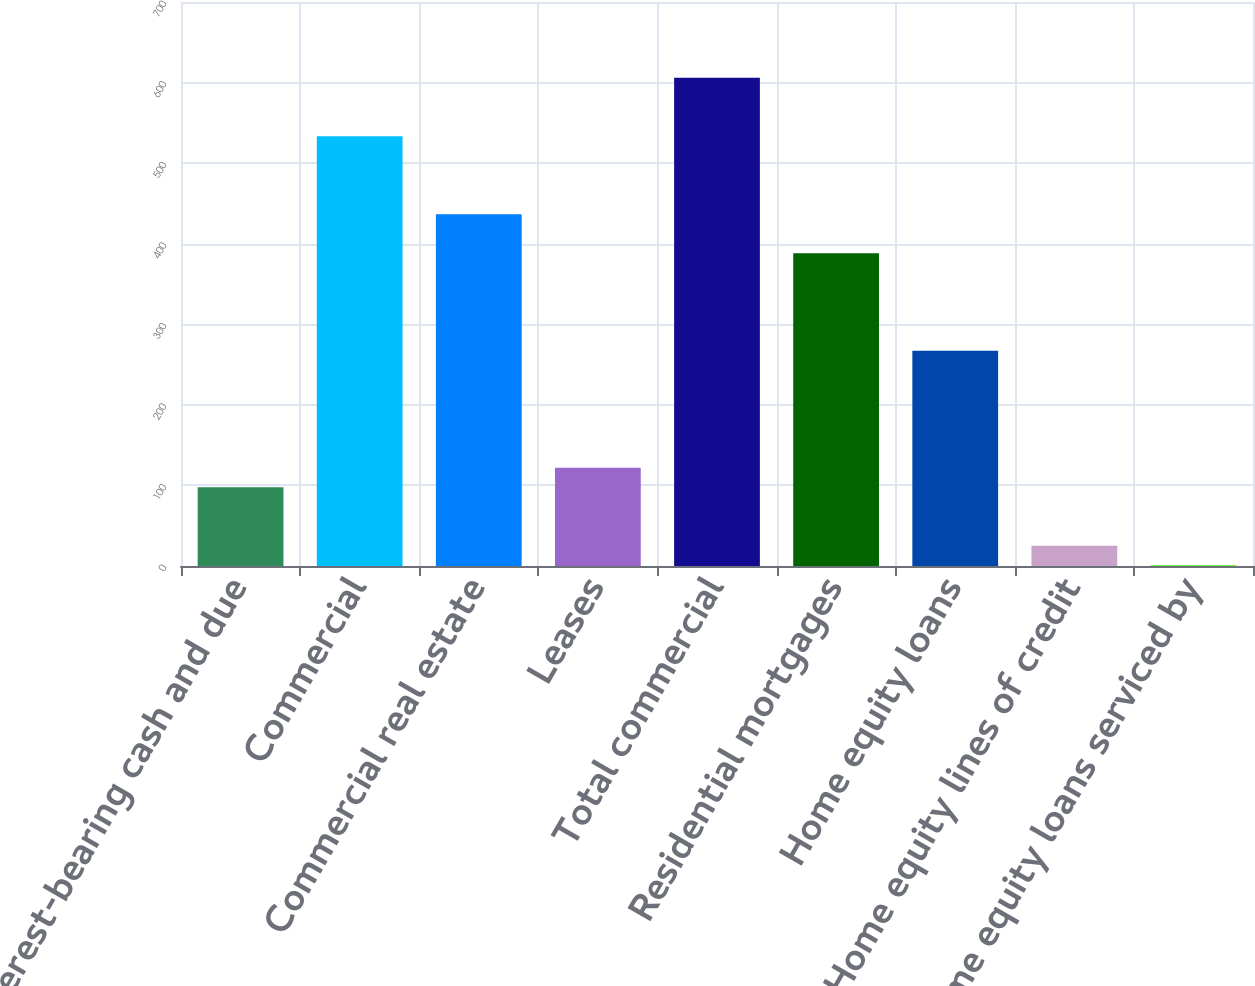Convert chart. <chart><loc_0><loc_0><loc_500><loc_500><bar_chart><fcel>Interest-bearing cash and due<fcel>Commercial<fcel>Commercial real estate<fcel>Leases<fcel>Total commercial<fcel>Residential mortgages<fcel>Home equity loans<fcel>Home equity lines of credit<fcel>Home equity loans serviced by<nl><fcel>97.8<fcel>533.4<fcel>436.6<fcel>122<fcel>606<fcel>388.2<fcel>267.2<fcel>25.2<fcel>1<nl></chart> 